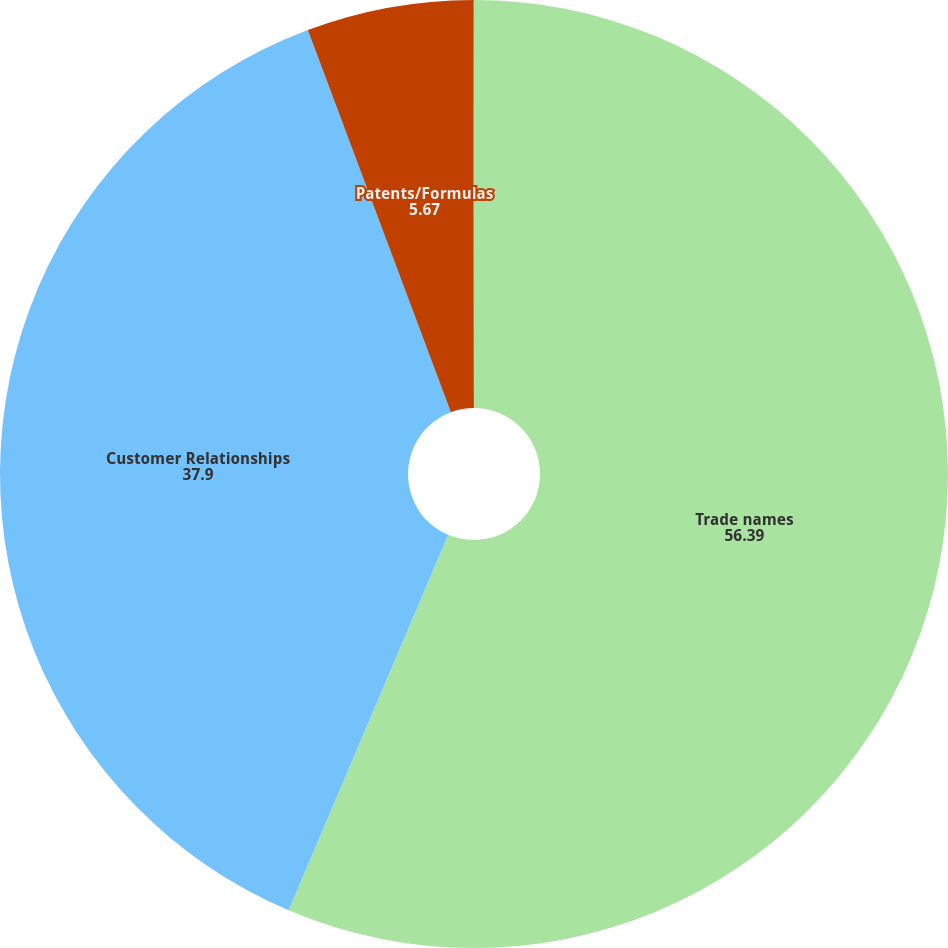Convert chart to OTSL. <chart><loc_0><loc_0><loc_500><loc_500><pie_chart><fcel>Trade names<fcel>Customer Relationships<fcel>Patents/Formulas<fcel>Non Compete Agreement<nl><fcel>56.39%<fcel>37.9%<fcel>5.67%<fcel>0.03%<nl></chart> 